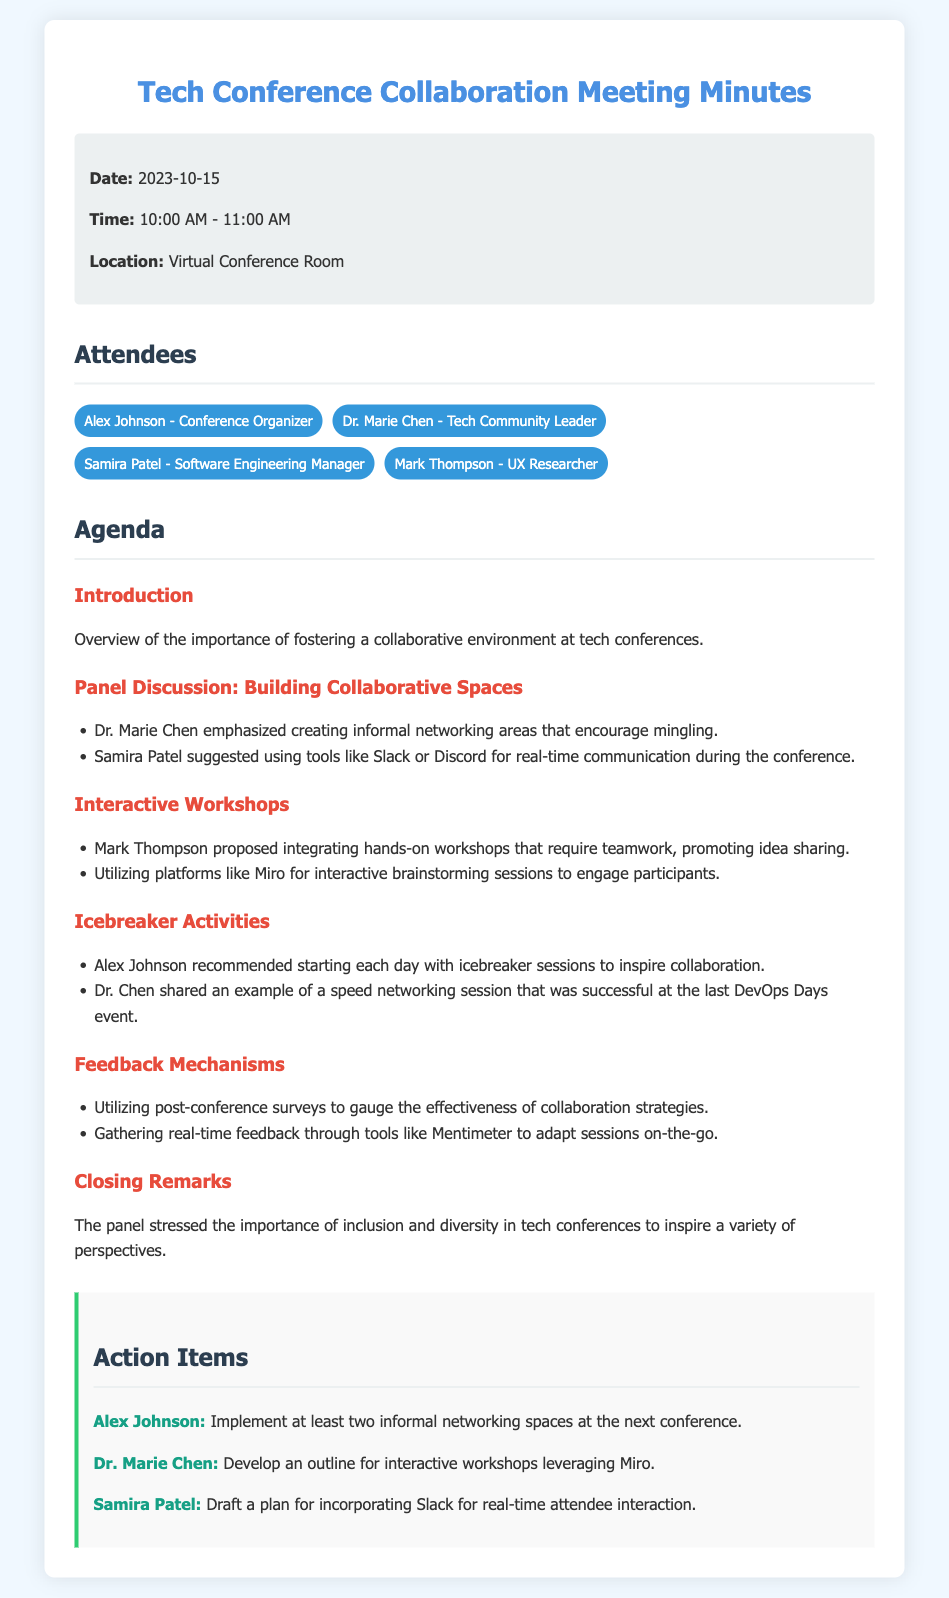what is the date of the meeting? The date of the meeting is clearly stated in the document as the date of the discussion.
Answer: 2023-10-15 who is the conference organizer? The name of the conference organizer is listed among the attendees in the document.
Answer: Alex Johnson what topic did Dr. Marie Chen emphasize during the panel discussion? The document mentions Dr. Marie Chen's contribution to the panel discussion regarding the creation of collaborative spaces.
Answer: Informal networking areas what tool was suggested by Samira Patel for real-time communication? Samira Patel's suggestion for enhancing communication among attendees is noted in the text.
Answer: Slack or Discord how many attendees are listed in the meeting minutes? The number of attendees is included in the list of attendees.
Answer: 4 what action item is assigned to Alex Johnson? Alex Johnson's specific action item is detailed in the action items section.
Answer: Implement at least two informal networking spaces what activity was recommended to start each day of the conference? The document outlines icebreaker sessions as a recommended activity for each day.
Answer: Icebreaker sessions what was the purpose of using post-conference surveys? The document explicitly states the reason for utilizing post-conference surveys in gauging effectiveness.
Answer: Gauge the effectiveness of collaboration strategies what was emphasized in the closing remarks? The closing remarks highlight a key topic discussed at the end of the meeting.
Answer: Inclusion and diversity in tech conferences 